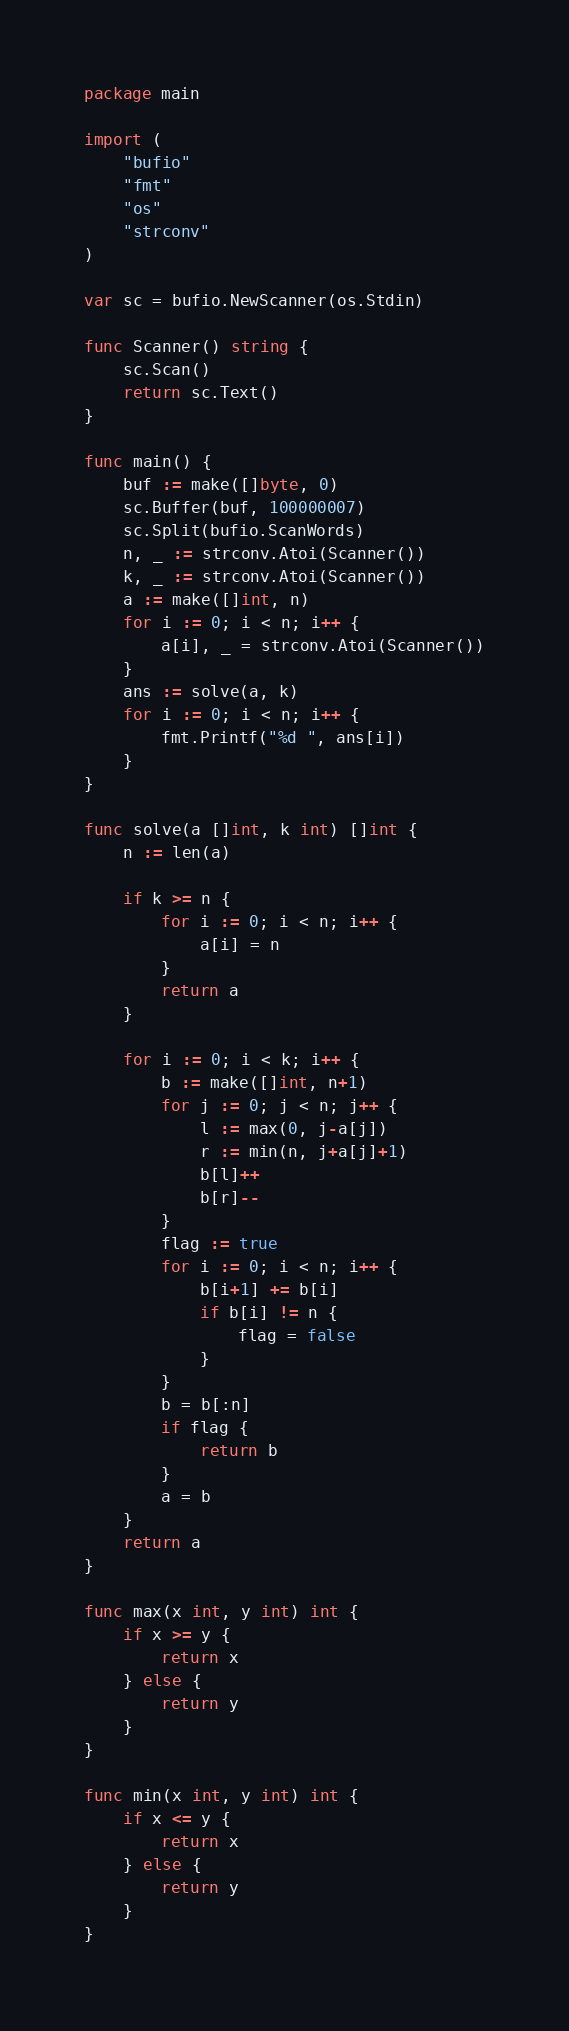Convert code to text. <code><loc_0><loc_0><loc_500><loc_500><_Go_>package main

import (
	"bufio"
	"fmt"
	"os"
	"strconv"
)

var sc = bufio.NewScanner(os.Stdin)

func Scanner() string {
	sc.Scan()
	return sc.Text()
}

func main() {
	buf := make([]byte, 0)
	sc.Buffer(buf, 100000007)
	sc.Split(bufio.ScanWords)
	n, _ := strconv.Atoi(Scanner())
	k, _ := strconv.Atoi(Scanner())
	a := make([]int, n)
	for i := 0; i < n; i++ {
		a[i], _ = strconv.Atoi(Scanner())
	}
	ans := solve(a, k)
	for i := 0; i < n; i++ {
		fmt.Printf("%d ", ans[i])
	}
}

func solve(a []int, k int) []int {
	n := len(a)

	if k >= n {
		for i := 0; i < n; i++ {
			a[i] = n
		}
		return a
	}

	for i := 0; i < k; i++ {
		b := make([]int, n+1)
		for j := 0; j < n; j++ {
			l := max(0, j-a[j])
			r := min(n, j+a[j]+1)
			b[l]++
			b[r]--
		}
		flag := true
		for i := 0; i < n; i++ {
			b[i+1] += b[i]
			if b[i] != n {
				flag = false
			}
		}
		b = b[:n]
		if flag {
			return b
		}
		a = b
	}
	return a
}

func max(x int, y int) int {
	if x >= y {
		return x
	} else {
		return y
	}
}

func min(x int, y int) int {
	if x <= y {
		return x
	} else {
		return y
	}
}</code> 